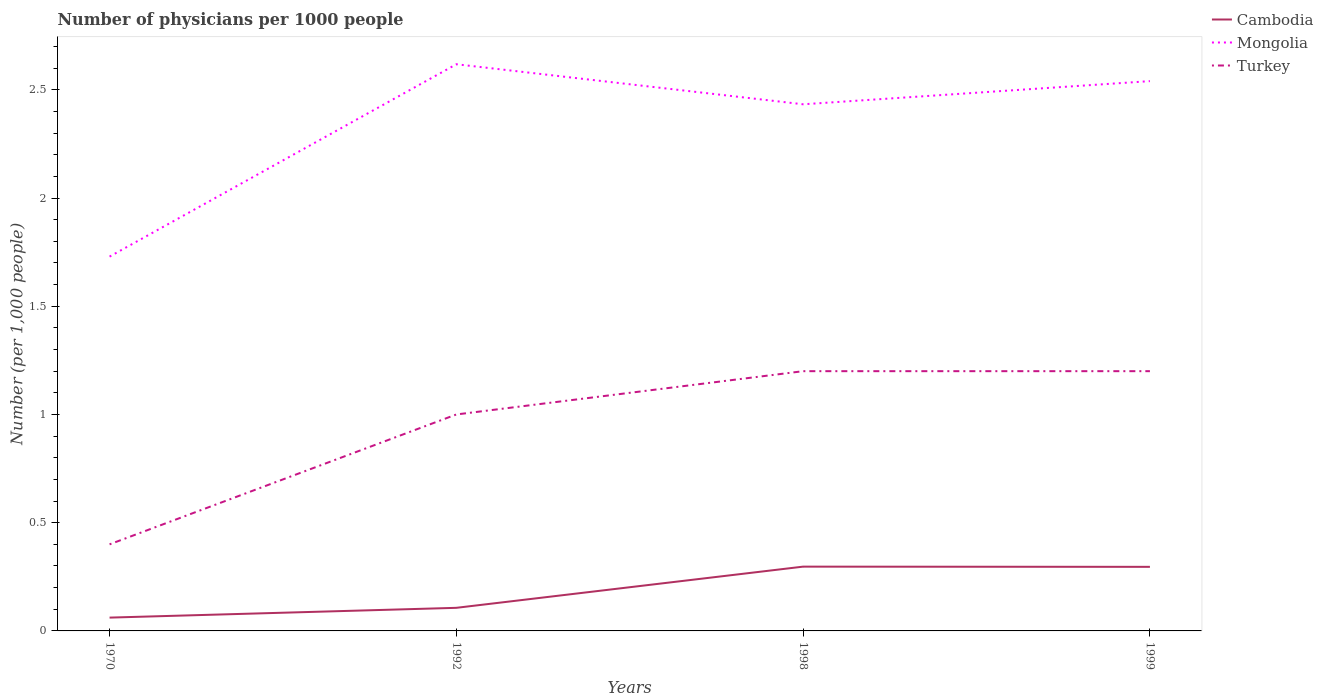How many different coloured lines are there?
Give a very brief answer. 3. Is the number of lines equal to the number of legend labels?
Your response must be concise. Yes. Across all years, what is the maximum number of physicians in Mongolia?
Keep it short and to the point. 1.73. What is the total number of physicians in Turkey in the graph?
Provide a short and direct response. -0.2. What is the difference between the highest and the second highest number of physicians in Mongolia?
Keep it short and to the point. 0.89. What is the difference between the highest and the lowest number of physicians in Mongolia?
Provide a short and direct response. 3. How many lines are there?
Offer a very short reply. 3. Are the values on the major ticks of Y-axis written in scientific E-notation?
Make the answer very short. No. Does the graph contain any zero values?
Offer a terse response. No. Does the graph contain grids?
Offer a terse response. No. How are the legend labels stacked?
Make the answer very short. Vertical. What is the title of the graph?
Offer a very short reply. Number of physicians per 1000 people. What is the label or title of the X-axis?
Make the answer very short. Years. What is the label or title of the Y-axis?
Provide a short and direct response. Number (per 1,0 people). What is the Number (per 1,000 people) of Cambodia in 1970?
Offer a very short reply. 0.06. What is the Number (per 1,000 people) of Mongolia in 1970?
Make the answer very short. 1.73. What is the Number (per 1,000 people) in Turkey in 1970?
Ensure brevity in your answer.  0.4. What is the Number (per 1,000 people) of Cambodia in 1992?
Ensure brevity in your answer.  0.11. What is the Number (per 1,000 people) in Mongolia in 1992?
Provide a short and direct response. 2.62. What is the Number (per 1,000 people) of Turkey in 1992?
Give a very brief answer. 1. What is the Number (per 1,000 people) in Cambodia in 1998?
Offer a terse response. 0.3. What is the Number (per 1,000 people) of Mongolia in 1998?
Offer a terse response. 2.43. What is the Number (per 1,000 people) in Cambodia in 1999?
Offer a terse response. 0.3. What is the Number (per 1,000 people) of Mongolia in 1999?
Offer a very short reply. 2.54. Across all years, what is the maximum Number (per 1,000 people) in Cambodia?
Make the answer very short. 0.3. Across all years, what is the maximum Number (per 1,000 people) of Mongolia?
Provide a succinct answer. 2.62. Across all years, what is the maximum Number (per 1,000 people) in Turkey?
Your response must be concise. 1.2. Across all years, what is the minimum Number (per 1,000 people) in Cambodia?
Make the answer very short. 0.06. Across all years, what is the minimum Number (per 1,000 people) of Mongolia?
Provide a short and direct response. 1.73. Across all years, what is the minimum Number (per 1,000 people) of Turkey?
Your answer should be compact. 0.4. What is the total Number (per 1,000 people) of Cambodia in the graph?
Your response must be concise. 0.76. What is the total Number (per 1,000 people) of Mongolia in the graph?
Your response must be concise. 9.32. What is the total Number (per 1,000 people) of Turkey in the graph?
Make the answer very short. 3.8. What is the difference between the Number (per 1,000 people) of Cambodia in 1970 and that in 1992?
Keep it short and to the point. -0.05. What is the difference between the Number (per 1,000 people) in Mongolia in 1970 and that in 1992?
Offer a terse response. -0.89. What is the difference between the Number (per 1,000 people) in Turkey in 1970 and that in 1992?
Give a very brief answer. -0.6. What is the difference between the Number (per 1,000 people) of Cambodia in 1970 and that in 1998?
Your answer should be compact. -0.24. What is the difference between the Number (per 1,000 people) of Mongolia in 1970 and that in 1998?
Offer a terse response. -0.7. What is the difference between the Number (per 1,000 people) of Cambodia in 1970 and that in 1999?
Your answer should be very brief. -0.23. What is the difference between the Number (per 1,000 people) in Mongolia in 1970 and that in 1999?
Offer a very short reply. -0.81. What is the difference between the Number (per 1,000 people) of Turkey in 1970 and that in 1999?
Your response must be concise. -0.8. What is the difference between the Number (per 1,000 people) in Cambodia in 1992 and that in 1998?
Provide a short and direct response. -0.19. What is the difference between the Number (per 1,000 people) of Mongolia in 1992 and that in 1998?
Your answer should be very brief. 0.18. What is the difference between the Number (per 1,000 people) of Cambodia in 1992 and that in 1999?
Your answer should be very brief. -0.19. What is the difference between the Number (per 1,000 people) of Mongolia in 1992 and that in 1999?
Ensure brevity in your answer.  0.08. What is the difference between the Number (per 1,000 people) in Turkey in 1992 and that in 1999?
Ensure brevity in your answer.  -0.2. What is the difference between the Number (per 1,000 people) of Cambodia in 1998 and that in 1999?
Give a very brief answer. 0. What is the difference between the Number (per 1,000 people) in Mongolia in 1998 and that in 1999?
Make the answer very short. -0.11. What is the difference between the Number (per 1,000 people) of Cambodia in 1970 and the Number (per 1,000 people) of Mongolia in 1992?
Provide a succinct answer. -2.56. What is the difference between the Number (per 1,000 people) of Cambodia in 1970 and the Number (per 1,000 people) of Turkey in 1992?
Your answer should be very brief. -0.94. What is the difference between the Number (per 1,000 people) of Mongolia in 1970 and the Number (per 1,000 people) of Turkey in 1992?
Offer a very short reply. 0.73. What is the difference between the Number (per 1,000 people) in Cambodia in 1970 and the Number (per 1,000 people) in Mongolia in 1998?
Your response must be concise. -2.37. What is the difference between the Number (per 1,000 people) in Cambodia in 1970 and the Number (per 1,000 people) in Turkey in 1998?
Make the answer very short. -1.14. What is the difference between the Number (per 1,000 people) of Mongolia in 1970 and the Number (per 1,000 people) of Turkey in 1998?
Offer a terse response. 0.53. What is the difference between the Number (per 1,000 people) of Cambodia in 1970 and the Number (per 1,000 people) of Mongolia in 1999?
Give a very brief answer. -2.48. What is the difference between the Number (per 1,000 people) in Cambodia in 1970 and the Number (per 1,000 people) in Turkey in 1999?
Offer a terse response. -1.14. What is the difference between the Number (per 1,000 people) of Mongolia in 1970 and the Number (per 1,000 people) of Turkey in 1999?
Provide a succinct answer. 0.53. What is the difference between the Number (per 1,000 people) of Cambodia in 1992 and the Number (per 1,000 people) of Mongolia in 1998?
Ensure brevity in your answer.  -2.33. What is the difference between the Number (per 1,000 people) in Cambodia in 1992 and the Number (per 1,000 people) in Turkey in 1998?
Offer a terse response. -1.09. What is the difference between the Number (per 1,000 people) of Mongolia in 1992 and the Number (per 1,000 people) of Turkey in 1998?
Offer a very short reply. 1.42. What is the difference between the Number (per 1,000 people) of Cambodia in 1992 and the Number (per 1,000 people) of Mongolia in 1999?
Your answer should be very brief. -2.43. What is the difference between the Number (per 1,000 people) of Cambodia in 1992 and the Number (per 1,000 people) of Turkey in 1999?
Offer a very short reply. -1.09. What is the difference between the Number (per 1,000 people) in Mongolia in 1992 and the Number (per 1,000 people) in Turkey in 1999?
Provide a short and direct response. 1.42. What is the difference between the Number (per 1,000 people) of Cambodia in 1998 and the Number (per 1,000 people) of Mongolia in 1999?
Provide a succinct answer. -2.24. What is the difference between the Number (per 1,000 people) in Cambodia in 1998 and the Number (per 1,000 people) in Turkey in 1999?
Offer a terse response. -0.9. What is the difference between the Number (per 1,000 people) in Mongolia in 1998 and the Number (per 1,000 people) in Turkey in 1999?
Give a very brief answer. 1.23. What is the average Number (per 1,000 people) of Cambodia per year?
Your answer should be compact. 0.19. What is the average Number (per 1,000 people) in Mongolia per year?
Provide a short and direct response. 2.33. In the year 1970, what is the difference between the Number (per 1,000 people) of Cambodia and Number (per 1,000 people) of Mongolia?
Ensure brevity in your answer.  -1.67. In the year 1970, what is the difference between the Number (per 1,000 people) of Cambodia and Number (per 1,000 people) of Turkey?
Your answer should be compact. -0.34. In the year 1970, what is the difference between the Number (per 1,000 people) in Mongolia and Number (per 1,000 people) in Turkey?
Offer a terse response. 1.33. In the year 1992, what is the difference between the Number (per 1,000 people) of Cambodia and Number (per 1,000 people) of Mongolia?
Provide a succinct answer. -2.51. In the year 1992, what is the difference between the Number (per 1,000 people) of Cambodia and Number (per 1,000 people) of Turkey?
Ensure brevity in your answer.  -0.89. In the year 1992, what is the difference between the Number (per 1,000 people) of Mongolia and Number (per 1,000 people) of Turkey?
Your answer should be compact. 1.62. In the year 1998, what is the difference between the Number (per 1,000 people) in Cambodia and Number (per 1,000 people) in Mongolia?
Your response must be concise. -2.14. In the year 1998, what is the difference between the Number (per 1,000 people) of Cambodia and Number (per 1,000 people) of Turkey?
Provide a succinct answer. -0.9. In the year 1998, what is the difference between the Number (per 1,000 people) of Mongolia and Number (per 1,000 people) of Turkey?
Your response must be concise. 1.23. In the year 1999, what is the difference between the Number (per 1,000 people) of Cambodia and Number (per 1,000 people) of Mongolia?
Your response must be concise. -2.24. In the year 1999, what is the difference between the Number (per 1,000 people) of Cambodia and Number (per 1,000 people) of Turkey?
Provide a succinct answer. -0.9. In the year 1999, what is the difference between the Number (per 1,000 people) of Mongolia and Number (per 1,000 people) of Turkey?
Make the answer very short. 1.34. What is the ratio of the Number (per 1,000 people) in Cambodia in 1970 to that in 1992?
Your response must be concise. 0.58. What is the ratio of the Number (per 1,000 people) in Mongolia in 1970 to that in 1992?
Give a very brief answer. 0.66. What is the ratio of the Number (per 1,000 people) in Turkey in 1970 to that in 1992?
Your response must be concise. 0.4. What is the ratio of the Number (per 1,000 people) of Cambodia in 1970 to that in 1998?
Your answer should be very brief. 0.21. What is the ratio of the Number (per 1,000 people) in Mongolia in 1970 to that in 1998?
Your response must be concise. 0.71. What is the ratio of the Number (per 1,000 people) in Turkey in 1970 to that in 1998?
Ensure brevity in your answer.  0.33. What is the ratio of the Number (per 1,000 people) of Cambodia in 1970 to that in 1999?
Your response must be concise. 0.21. What is the ratio of the Number (per 1,000 people) of Mongolia in 1970 to that in 1999?
Offer a very short reply. 0.68. What is the ratio of the Number (per 1,000 people) of Cambodia in 1992 to that in 1998?
Offer a very short reply. 0.36. What is the ratio of the Number (per 1,000 people) in Mongolia in 1992 to that in 1998?
Provide a short and direct response. 1.08. What is the ratio of the Number (per 1,000 people) in Cambodia in 1992 to that in 1999?
Your answer should be very brief. 0.36. What is the ratio of the Number (per 1,000 people) in Mongolia in 1992 to that in 1999?
Ensure brevity in your answer.  1.03. What is the ratio of the Number (per 1,000 people) of Cambodia in 1998 to that in 1999?
Give a very brief answer. 1. What is the ratio of the Number (per 1,000 people) of Mongolia in 1998 to that in 1999?
Offer a very short reply. 0.96. What is the ratio of the Number (per 1,000 people) in Turkey in 1998 to that in 1999?
Provide a short and direct response. 1. What is the difference between the highest and the second highest Number (per 1,000 people) of Mongolia?
Provide a succinct answer. 0.08. What is the difference between the highest and the second highest Number (per 1,000 people) of Turkey?
Give a very brief answer. 0. What is the difference between the highest and the lowest Number (per 1,000 people) in Cambodia?
Offer a terse response. 0.24. What is the difference between the highest and the lowest Number (per 1,000 people) of Mongolia?
Provide a succinct answer. 0.89. What is the difference between the highest and the lowest Number (per 1,000 people) in Turkey?
Keep it short and to the point. 0.8. 